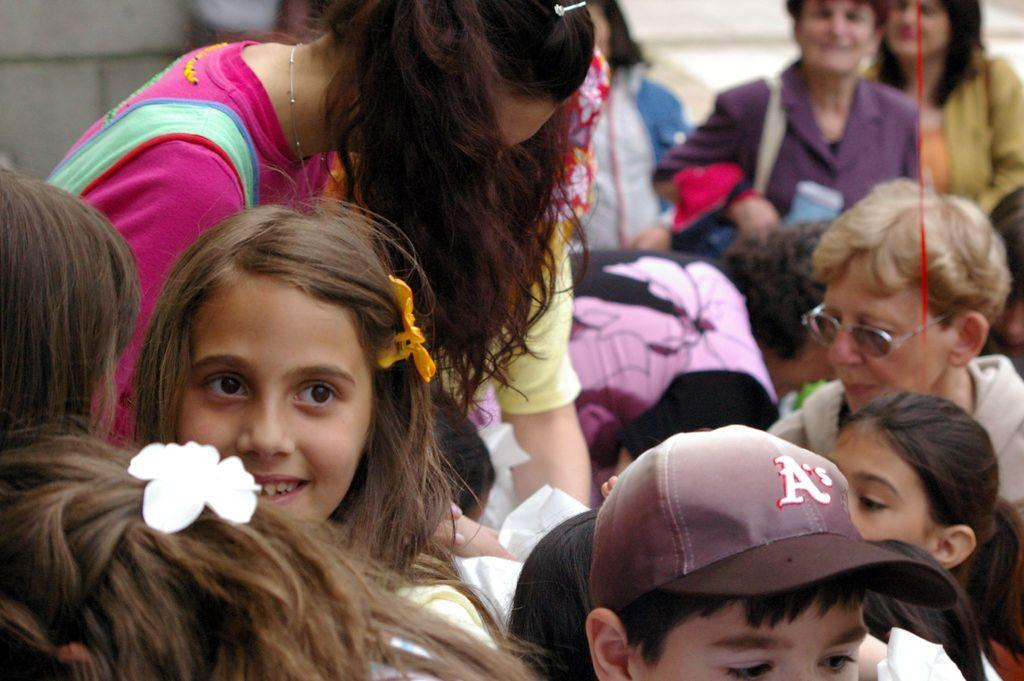What can be seen in the image? There are groups of people in the image. What else is visible in the image? There is a wall visible in the image. What type of button can be seen on the wall in the image? There is no button visible on the wall in the image. 